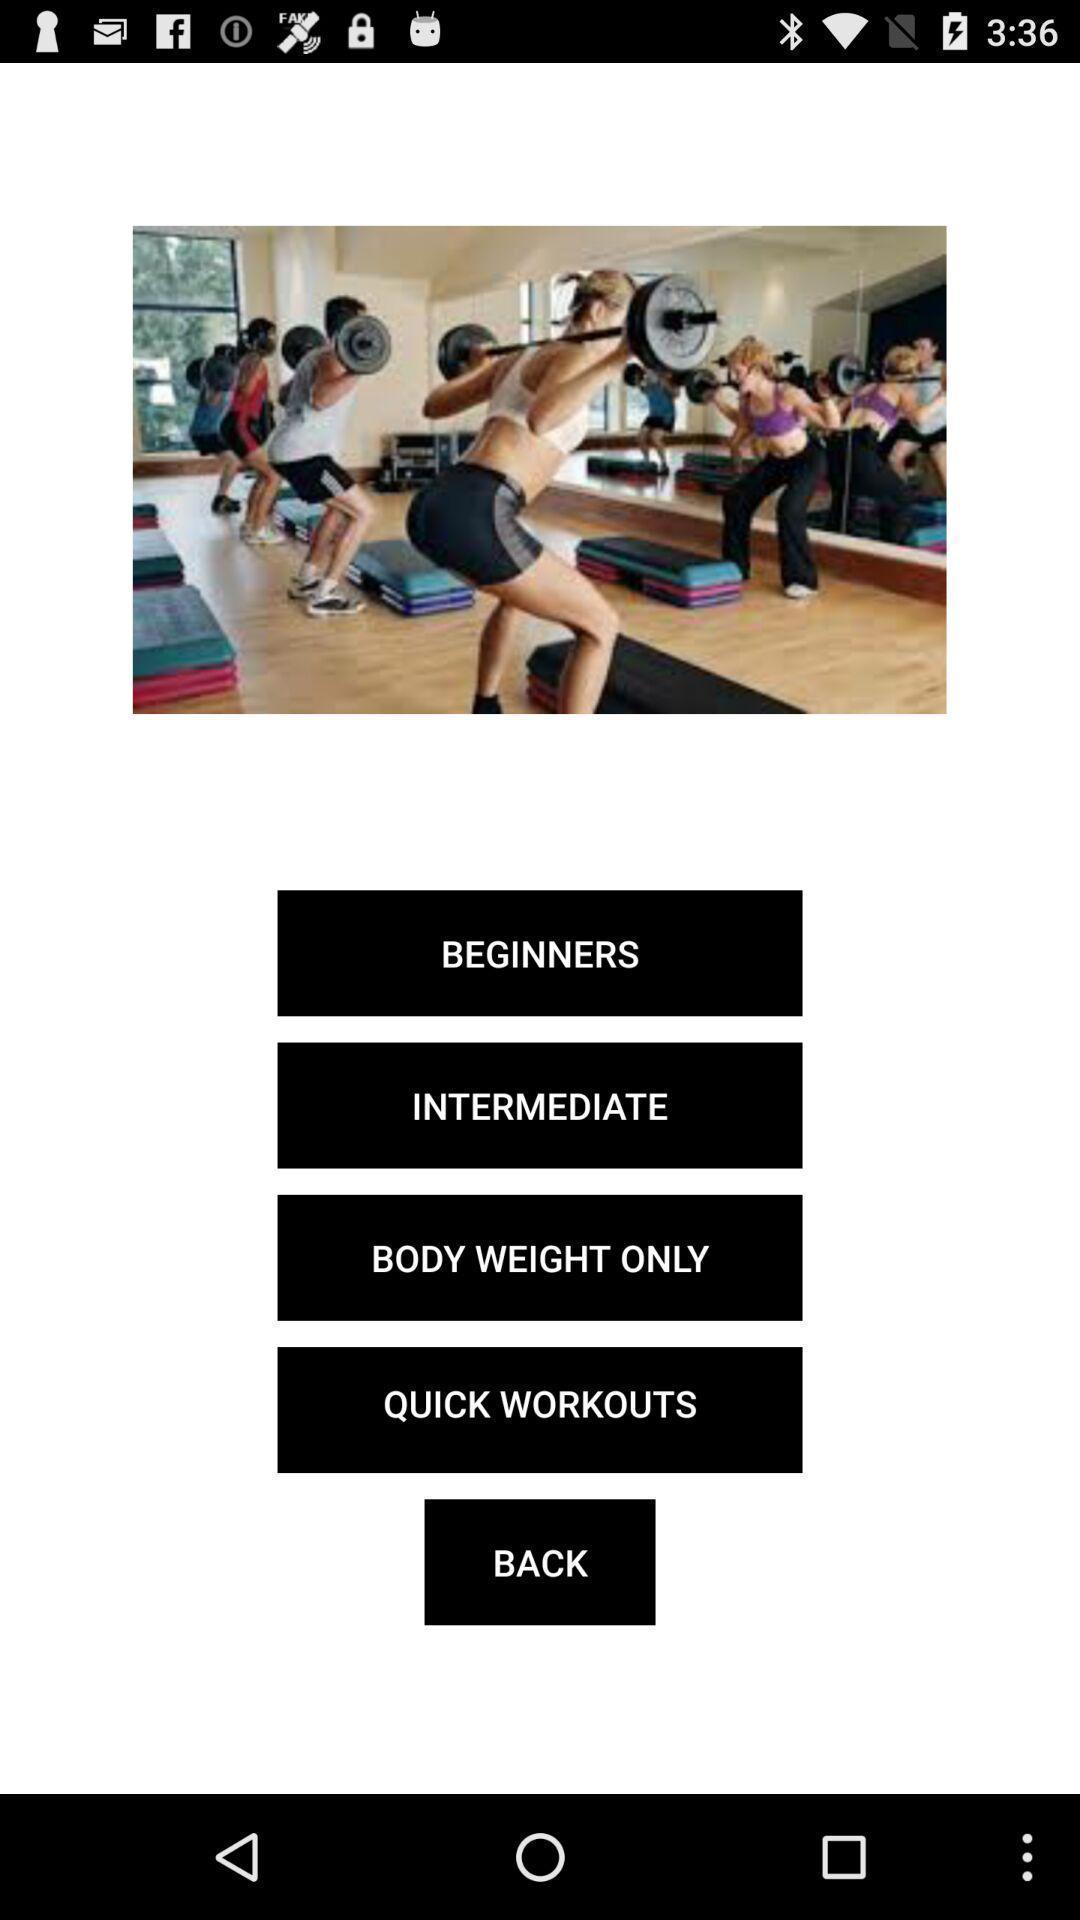Summarize the information in this screenshot. Page displaying an image and list of workout options. 